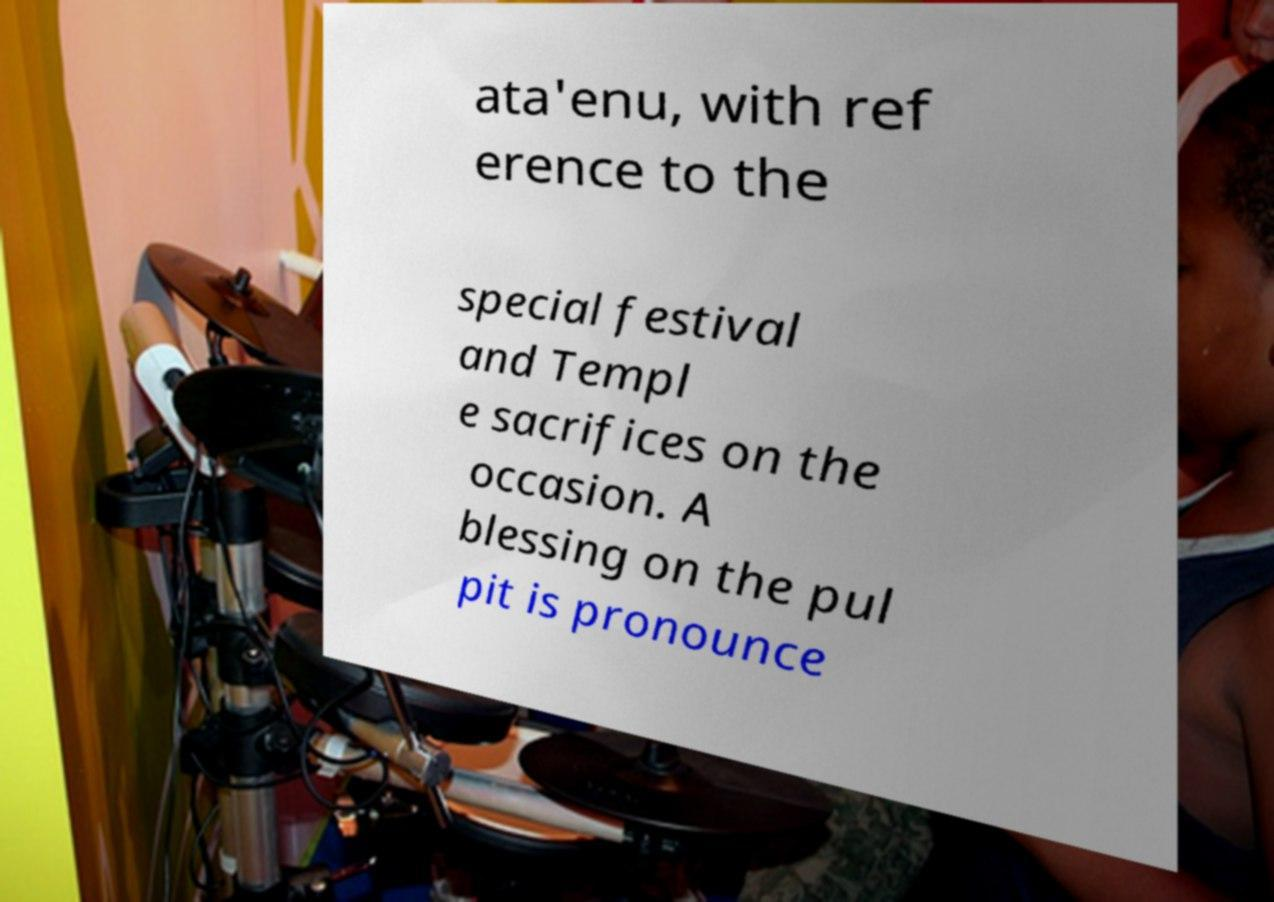Can you read and provide the text displayed in the image?This photo seems to have some interesting text. Can you extract and type it out for me? ata'enu, with ref erence to the special festival and Templ e sacrifices on the occasion. A blessing on the pul pit is pronounce 